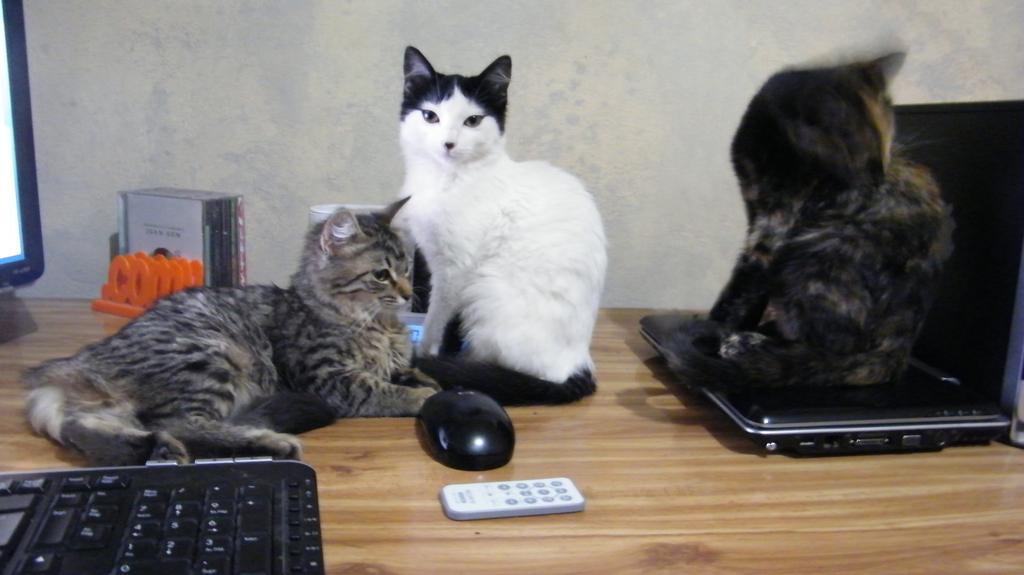How would you summarize this image in a sentence or two? In this image there are cats in the center and there are laptops, there is a mouse, and there is a remote. On the left side there is a monitor and the cat is sitting on the laptop which is on the right side and there are CD's and there is a wall which is white in colour in the background. 